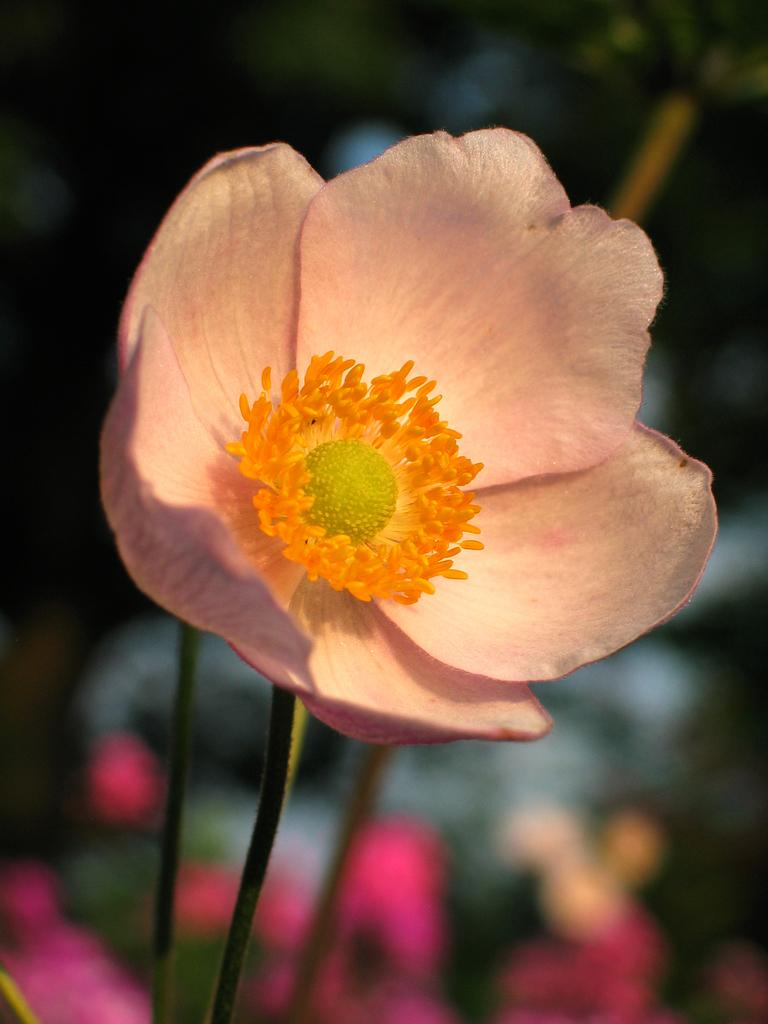What is the main subject of the image? There is a flower in the image. Can you describe the background of the image? The background of the image is blurred. What type of fire station can be seen in the background of the image? There is no fire station or any reference to a fire station in the image; it features a flower with a blurred background. 